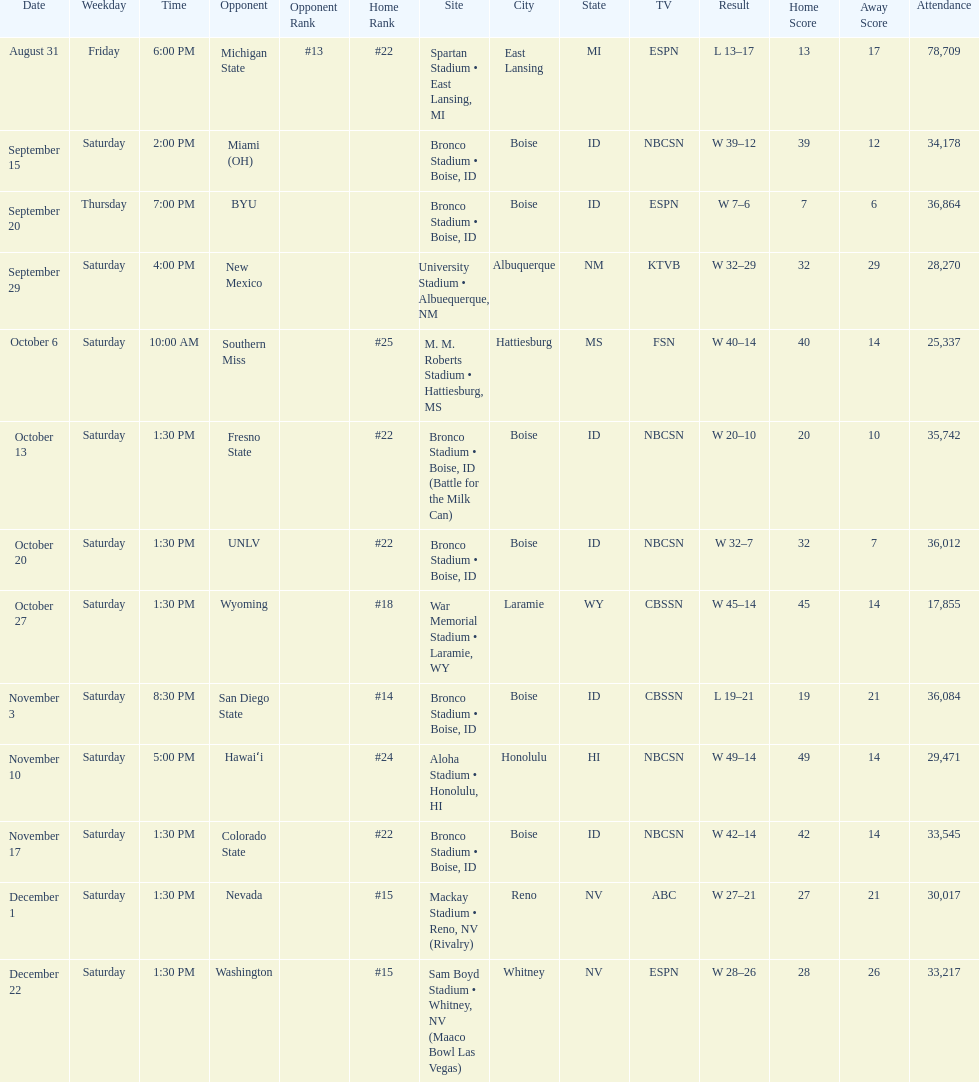What rank was boise state after november 10th? #22. 